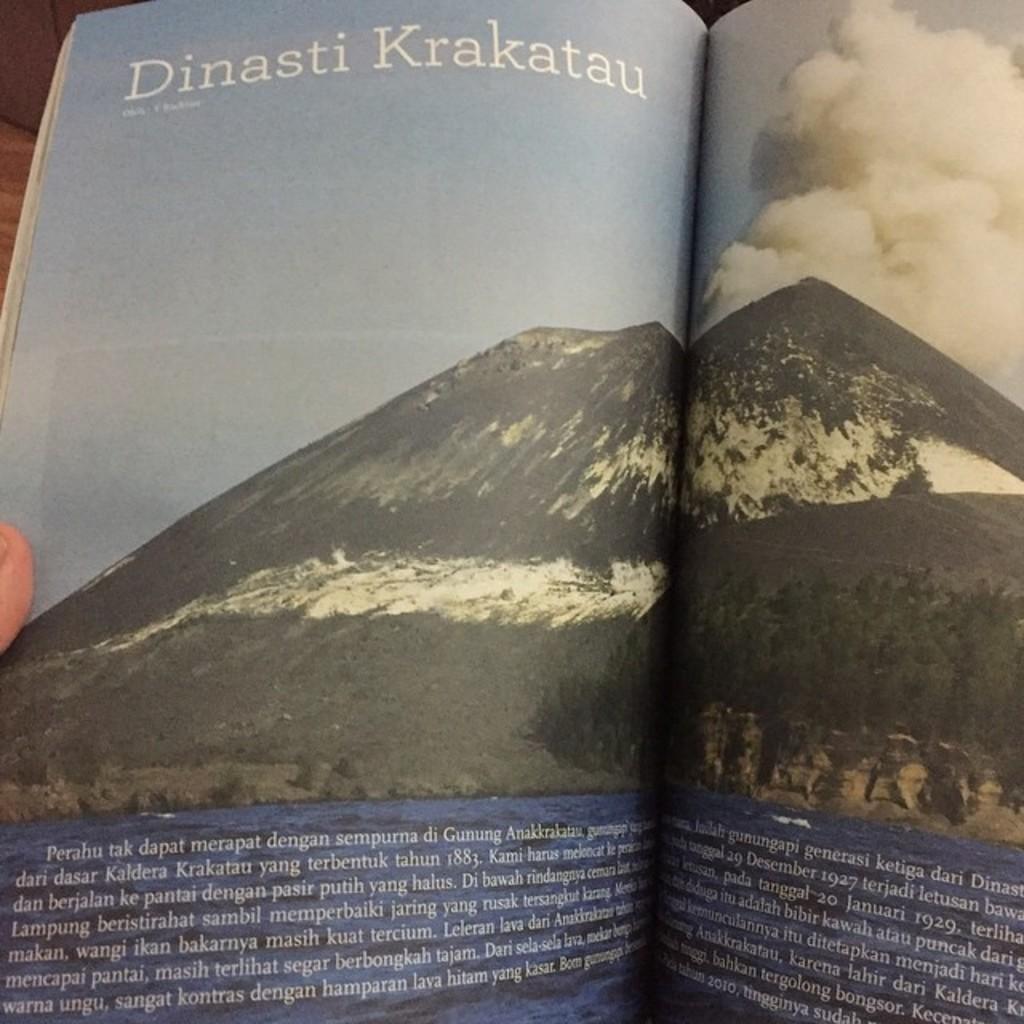What is the first word in the article?
Keep it short and to the point. Perahu. 